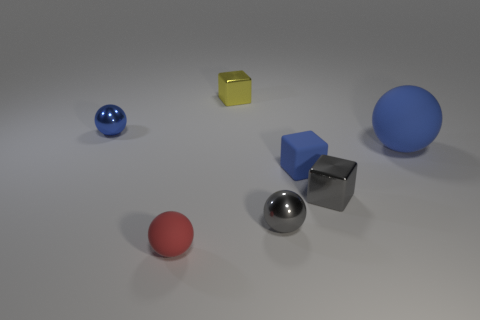Subtract 1 balls. How many balls are left? 3 Add 1 large gray balls. How many objects exist? 8 Subtract all blocks. How many objects are left? 4 Subtract all rubber spheres. Subtract all yellow metallic things. How many objects are left? 4 Add 4 rubber blocks. How many rubber blocks are left? 5 Add 1 big brown rubber balls. How many big brown rubber balls exist? 1 Subtract 0 cyan spheres. How many objects are left? 7 